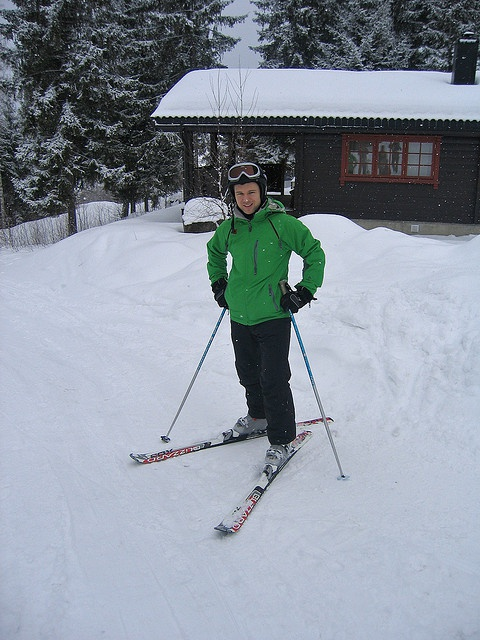Describe the objects in this image and their specific colors. I can see people in darkgray, black, darkgreen, and gray tones and skis in darkgray, gray, and black tones in this image. 